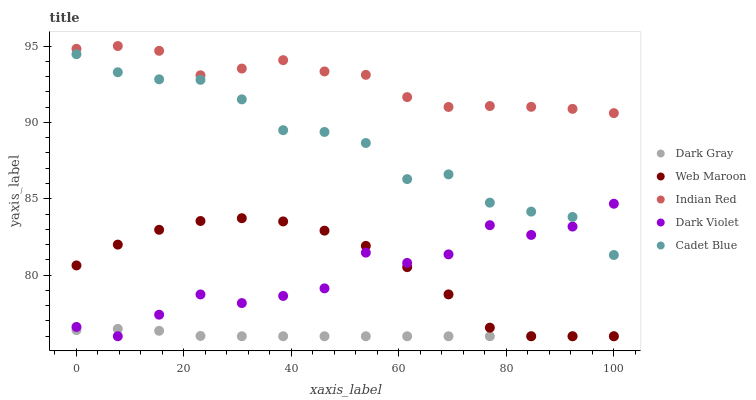Does Dark Gray have the minimum area under the curve?
Answer yes or no. Yes. Does Indian Red have the maximum area under the curve?
Answer yes or no. Yes. Does Cadet Blue have the minimum area under the curve?
Answer yes or no. No. Does Cadet Blue have the maximum area under the curve?
Answer yes or no. No. Is Dark Gray the smoothest?
Answer yes or no. Yes. Is Dark Violet the roughest?
Answer yes or no. Yes. Is Cadet Blue the smoothest?
Answer yes or no. No. Is Cadet Blue the roughest?
Answer yes or no. No. Does Dark Gray have the lowest value?
Answer yes or no. Yes. Does Cadet Blue have the lowest value?
Answer yes or no. No. Does Indian Red have the highest value?
Answer yes or no. Yes. Does Cadet Blue have the highest value?
Answer yes or no. No. Is Cadet Blue less than Indian Red?
Answer yes or no. Yes. Is Indian Red greater than Cadet Blue?
Answer yes or no. Yes. Does Dark Gray intersect Web Maroon?
Answer yes or no. Yes. Is Dark Gray less than Web Maroon?
Answer yes or no. No. Is Dark Gray greater than Web Maroon?
Answer yes or no. No. Does Cadet Blue intersect Indian Red?
Answer yes or no. No. 